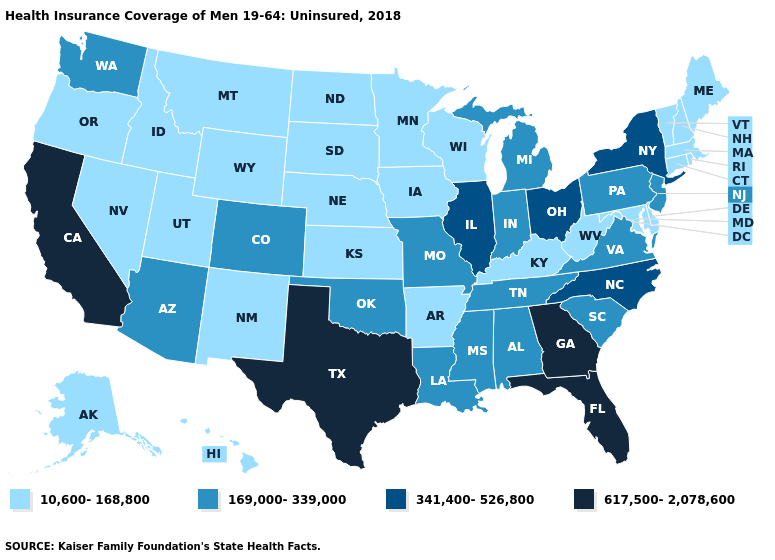Name the states that have a value in the range 617,500-2,078,600?
Write a very short answer. California, Florida, Georgia, Texas. What is the highest value in the USA?
Answer briefly. 617,500-2,078,600. Which states have the lowest value in the USA?
Give a very brief answer. Alaska, Arkansas, Connecticut, Delaware, Hawaii, Idaho, Iowa, Kansas, Kentucky, Maine, Maryland, Massachusetts, Minnesota, Montana, Nebraska, Nevada, New Hampshire, New Mexico, North Dakota, Oregon, Rhode Island, South Dakota, Utah, Vermont, West Virginia, Wisconsin, Wyoming. Name the states that have a value in the range 169,000-339,000?
Answer briefly. Alabama, Arizona, Colorado, Indiana, Louisiana, Michigan, Mississippi, Missouri, New Jersey, Oklahoma, Pennsylvania, South Carolina, Tennessee, Virginia, Washington. Name the states that have a value in the range 617,500-2,078,600?
Write a very short answer. California, Florida, Georgia, Texas. Name the states that have a value in the range 10,600-168,800?
Be succinct. Alaska, Arkansas, Connecticut, Delaware, Hawaii, Idaho, Iowa, Kansas, Kentucky, Maine, Maryland, Massachusetts, Minnesota, Montana, Nebraska, Nevada, New Hampshire, New Mexico, North Dakota, Oregon, Rhode Island, South Dakota, Utah, Vermont, West Virginia, Wisconsin, Wyoming. Does Nevada have the lowest value in the USA?
Be succinct. Yes. Name the states that have a value in the range 10,600-168,800?
Give a very brief answer. Alaska, Arkansas, Connecticut, Delaware, Hawaii, Idaho, Iowa, Kansas, Kentucky, Maine, Maryland, Massachusetts, Minnesota, Montana, Nebraska, Nevada, New Hampshire, New Mexico, North Dakota, Oregon, Rhode Island, South Dakota, Utah, Vermont, West Virginia, Wisconsin, Wyoming. What is the lowest value in states that border Florida?
Answer briefly. 169,000-339,000. What is the value of New Hampshire?
Answer briefly. 10,600-168,800. What is the highest value in the USA?
Concise answer only. 617,500-2,078,600. Name the states that have a value in the range 617,500-2,078,600?
Short answer required. California, Florida, Georgia, Texas. Among the states that border Rhode Island , which have the lowest value?
Quick response, please. Connecticut, Massachusetts. Does the first symbol in the legend represent the smallest category?
Keep it brief. Yes. Among the states that border Illinois , does Iowa have the highest value?
Concise answer only. No. 